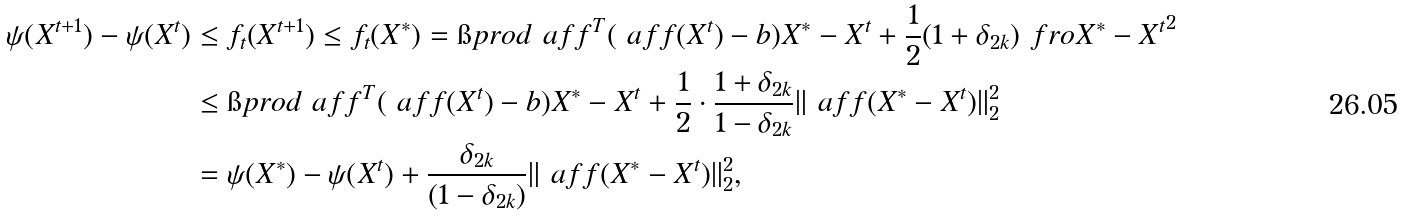Convert formula to latex. <formula><loc_0><loc_0><loc_500><loc_500>\psi ( X ^ { t + 1 } ) - \psi ( X ^ { t } ) & \leq f _ { t } ( X ^ { t + 1 } ) \leq f _ { t } ( X ^ { * } ) = \i p r o d { \ a f f ^ { T } ( \ a f f ( X ^ { t } ) - b ) } { X ^ { * } - X ^ { t } } + \frac { 1 } { 2 } ( 1 + \delta _ { 2 k } ) \ f r o { X ^ { * } - X ^ { t } } ^ { 2 } \\ & \leq \i p r o d { \ a f f ^ { T } ( \ a f f ( X ^ { t } ) - b ) } { X ^ { * } - X ^ { t } } + \frac { 1 } { 2 } \cdot \frac { 1 + \delta _ { 2 k } } { 1 - \delta _ { 2 k } } \| \ a f f ( X ^ { * } - X ^ { t } ) \| _ { 2 } ^ { 2 } \\ & = \psi ( X ^ { * } ) - \psi ( X ^ { t } ) + \frac { \delta _ { 2 k } } { ( 1 - \delta _ { 2 k } ) } \| \ a f f ( X ^ { * } - X ^ { t } ) \| _ { 2 } ^ { 2 } ,</formula> 